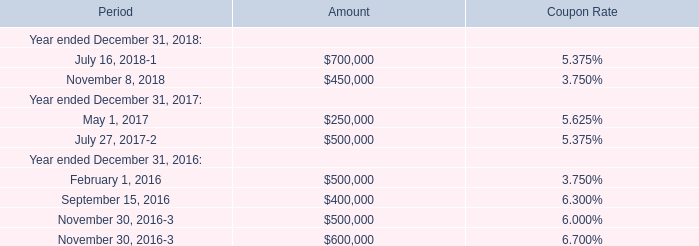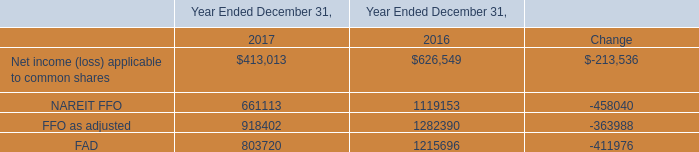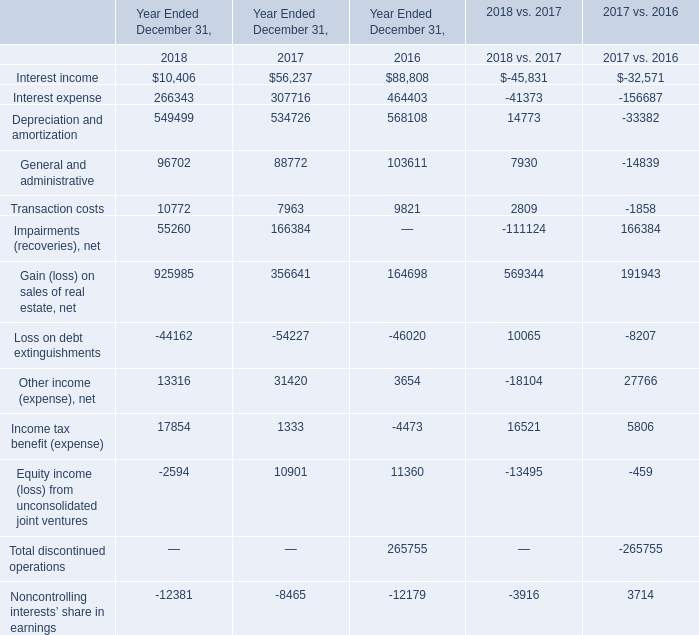What do all Year Ended December 31, sum up in 2018 for Year Ended December 31, , excluding Interest income and Interest expense? 
Computations: (((((((((549499 + 96702) + 10772) + 55260) + 925985) - 44162) + 13316) + 17854) - 2594) - 12381)
Answer: 1610251.0. 